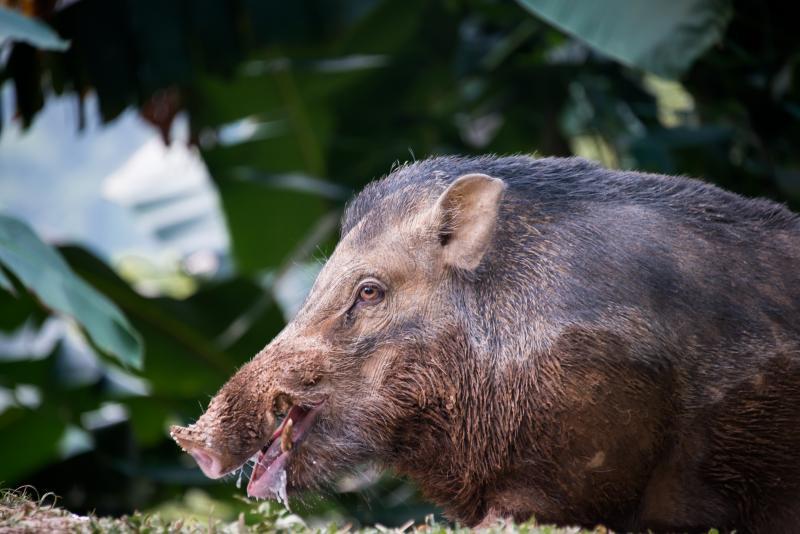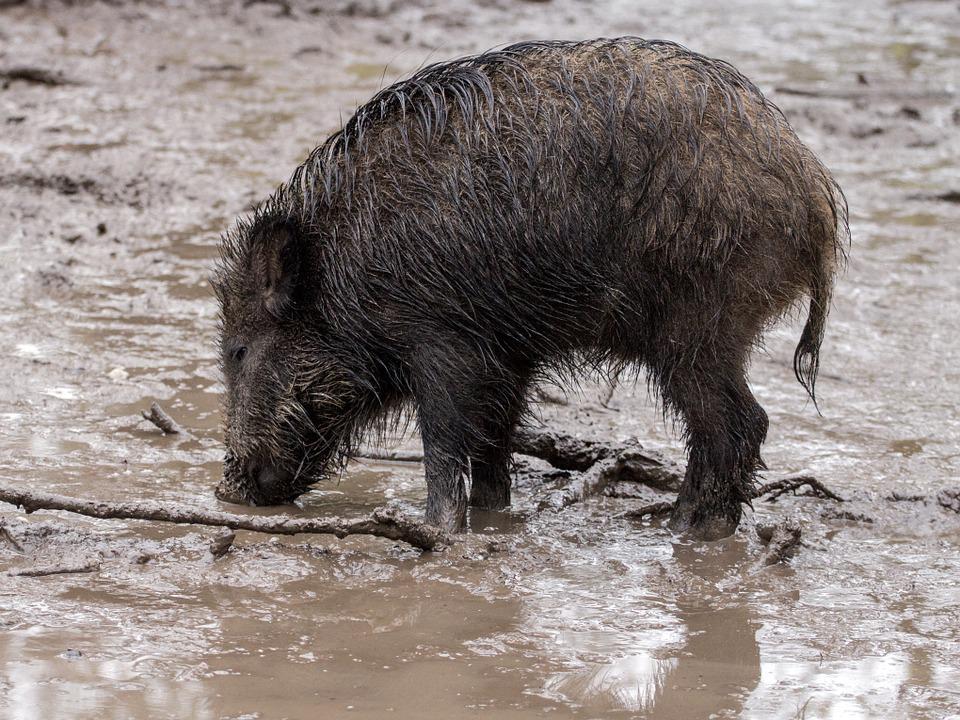The first image is the image on the left, the second image is the image on the right. Analyze the images presented: Is the assertion "Each image shows only one pig and in one of the images that pig is in the mud." valid? Answer yes or no. Yes. The first image is the image on the left, the second image is the image on the right. Examine the images to the left and right. Is the description "In the image on the right there is one black wild boar outdoors." accurate? Answer yes or no. Yes. 